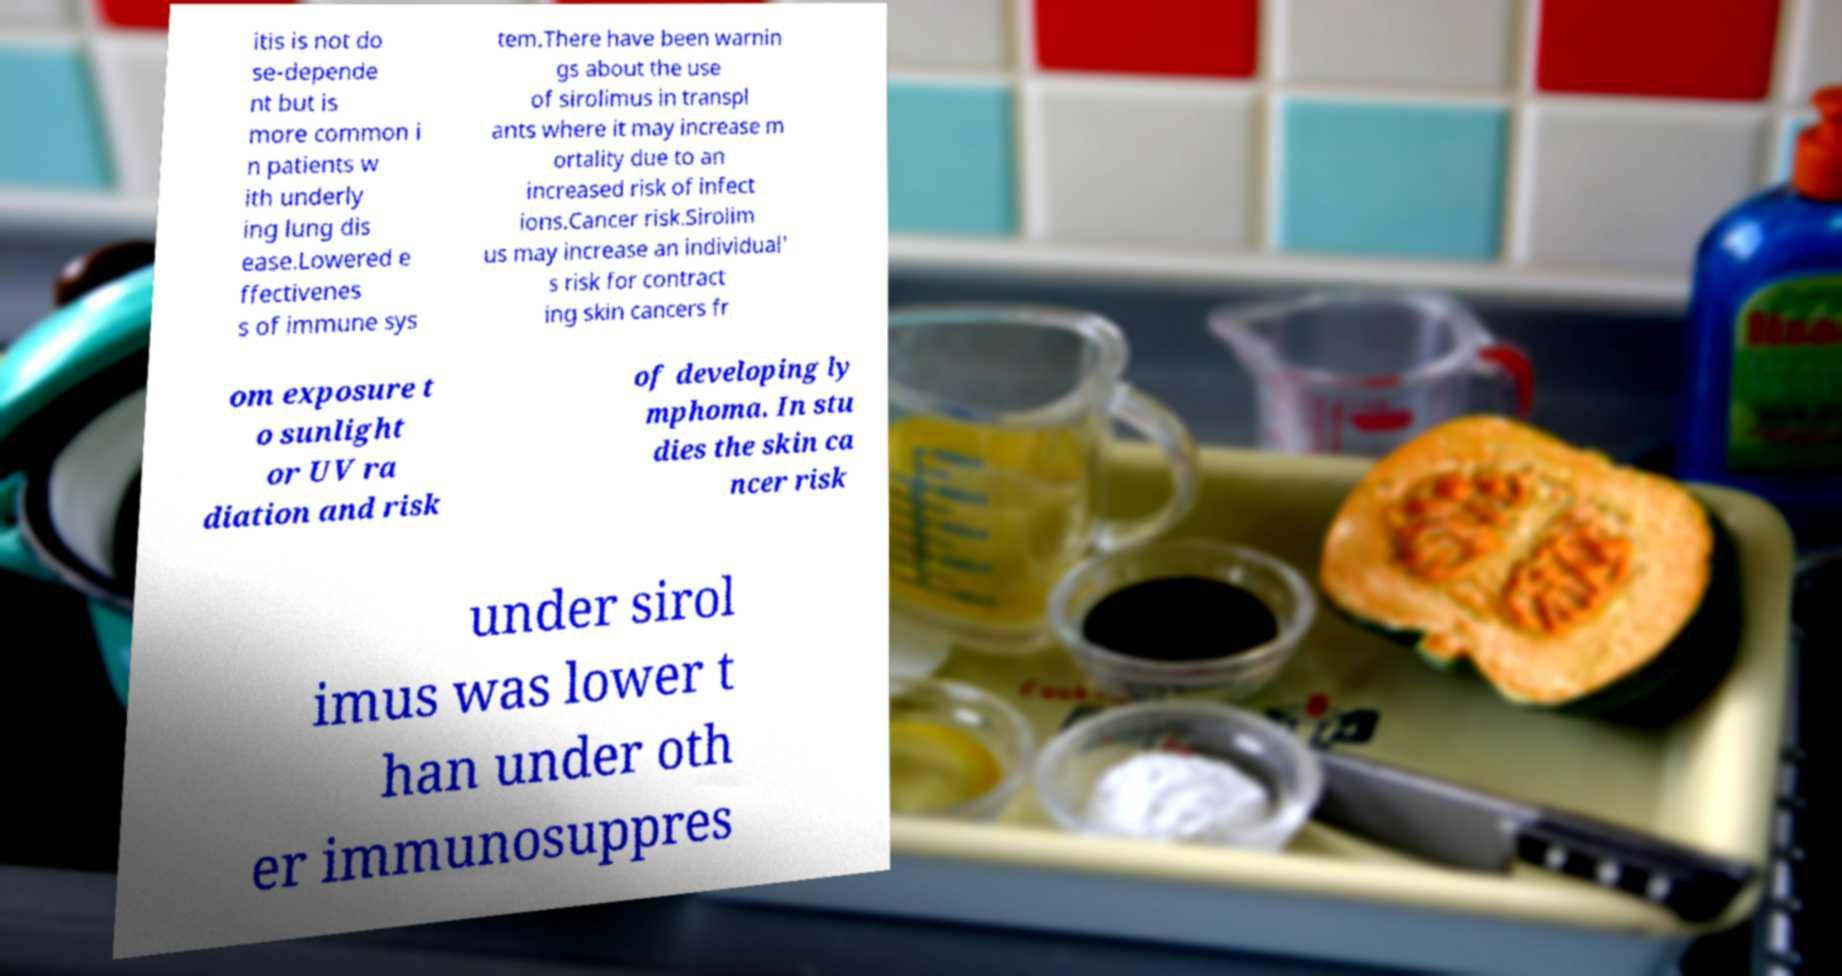Can you read and provide the text displayed in the image?This photo seems to have some interesting text. Can you extract and type it out for me? itis is not do se-depende nt but is more common i n patients w ith underly ing lung dis ease.Lowered e ffectivenes s of immune sys tem.There have been warnin gs about the use of sirolimus in transpl ants where it may increase m ortality due to an increased risk of infect ions.Cancer risk.Sirolim us may increase an individual' s risk for contract ing skin cancers fr om exposure t o sunlight or UV ra diation and risk of developing ly mphoma. In stu dies the skin ca ncer risk under sirol imus was lower t han under oth er immunosuppres 